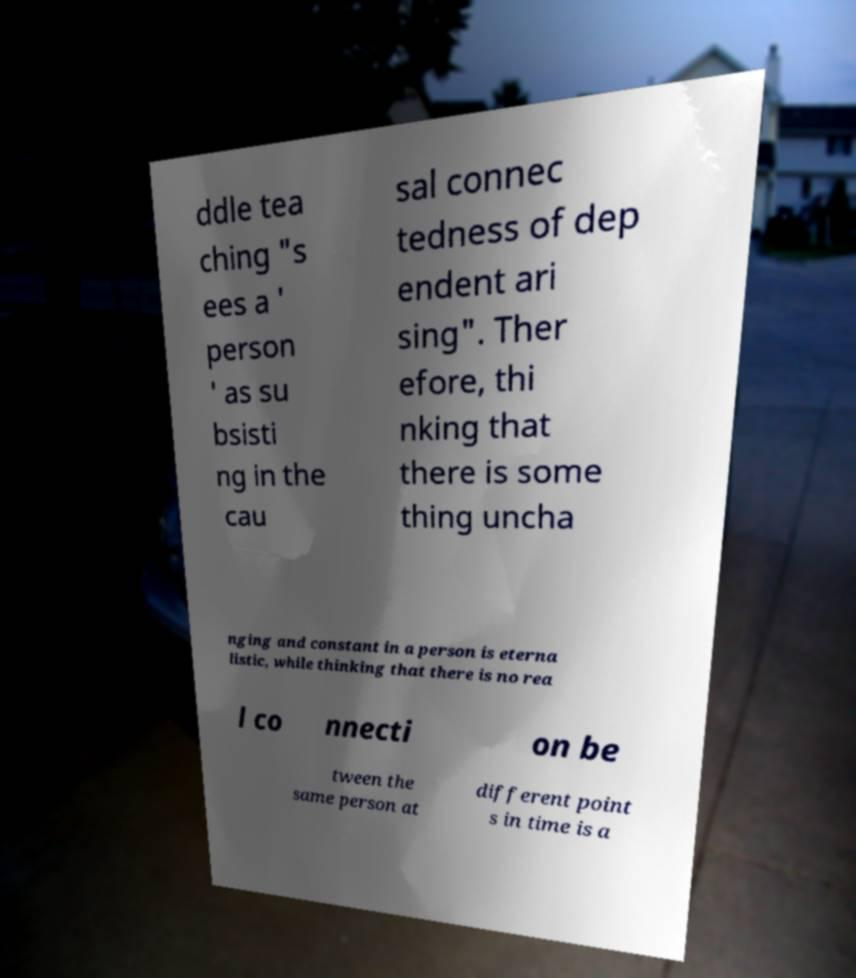Please identify and transcribe the text found in this image. ddle tea ching "s ees a ' person ' as su bsisti ng in the cau sal connec tedness of dep endent ari sing". Ther efore, thi nking that there is some thing uncha nging and constant in a person is eterna listic, while thinking that there is no rea l co nnecti on be tween the same person at different point s in time is a 